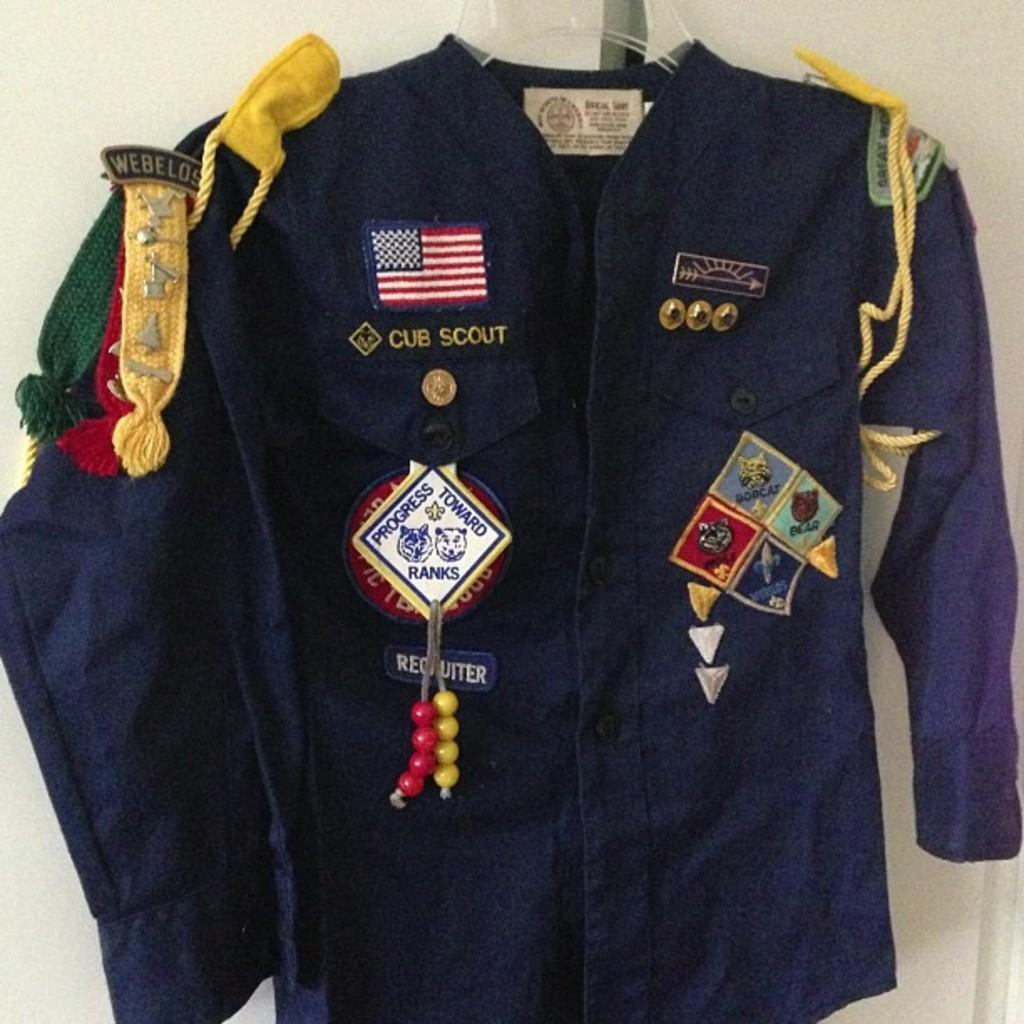<image>
Relay a brief, clear account of the picture shown. Cub Scout Shirt with many awards and with the United States Flag logo. 